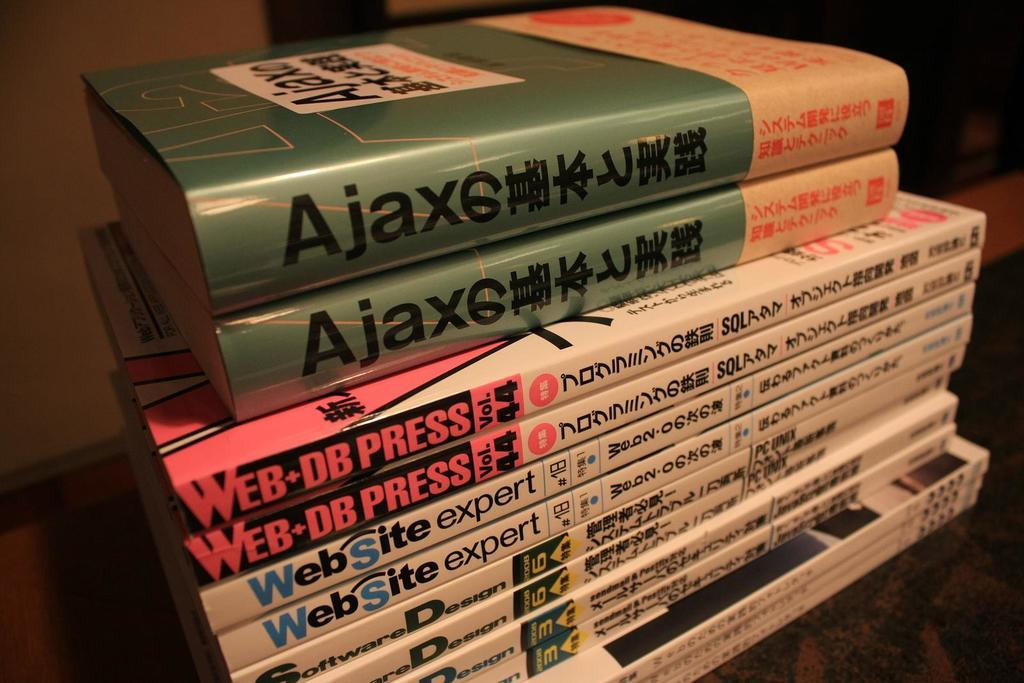<image>
Provide a brief description of the given image. Website Expert, Web DB Press, and Ajax books on top of each other. 